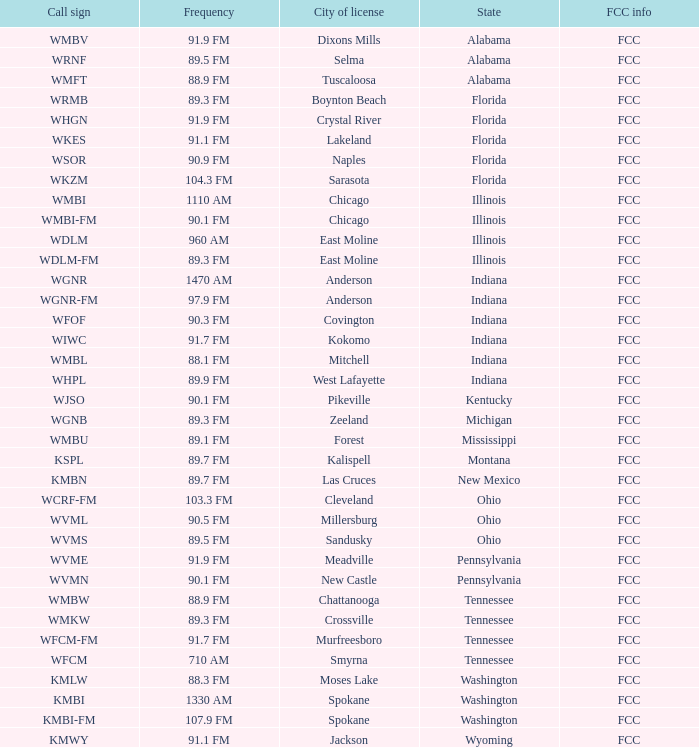What city is 103.3 FM licensed in? Cleveland. 